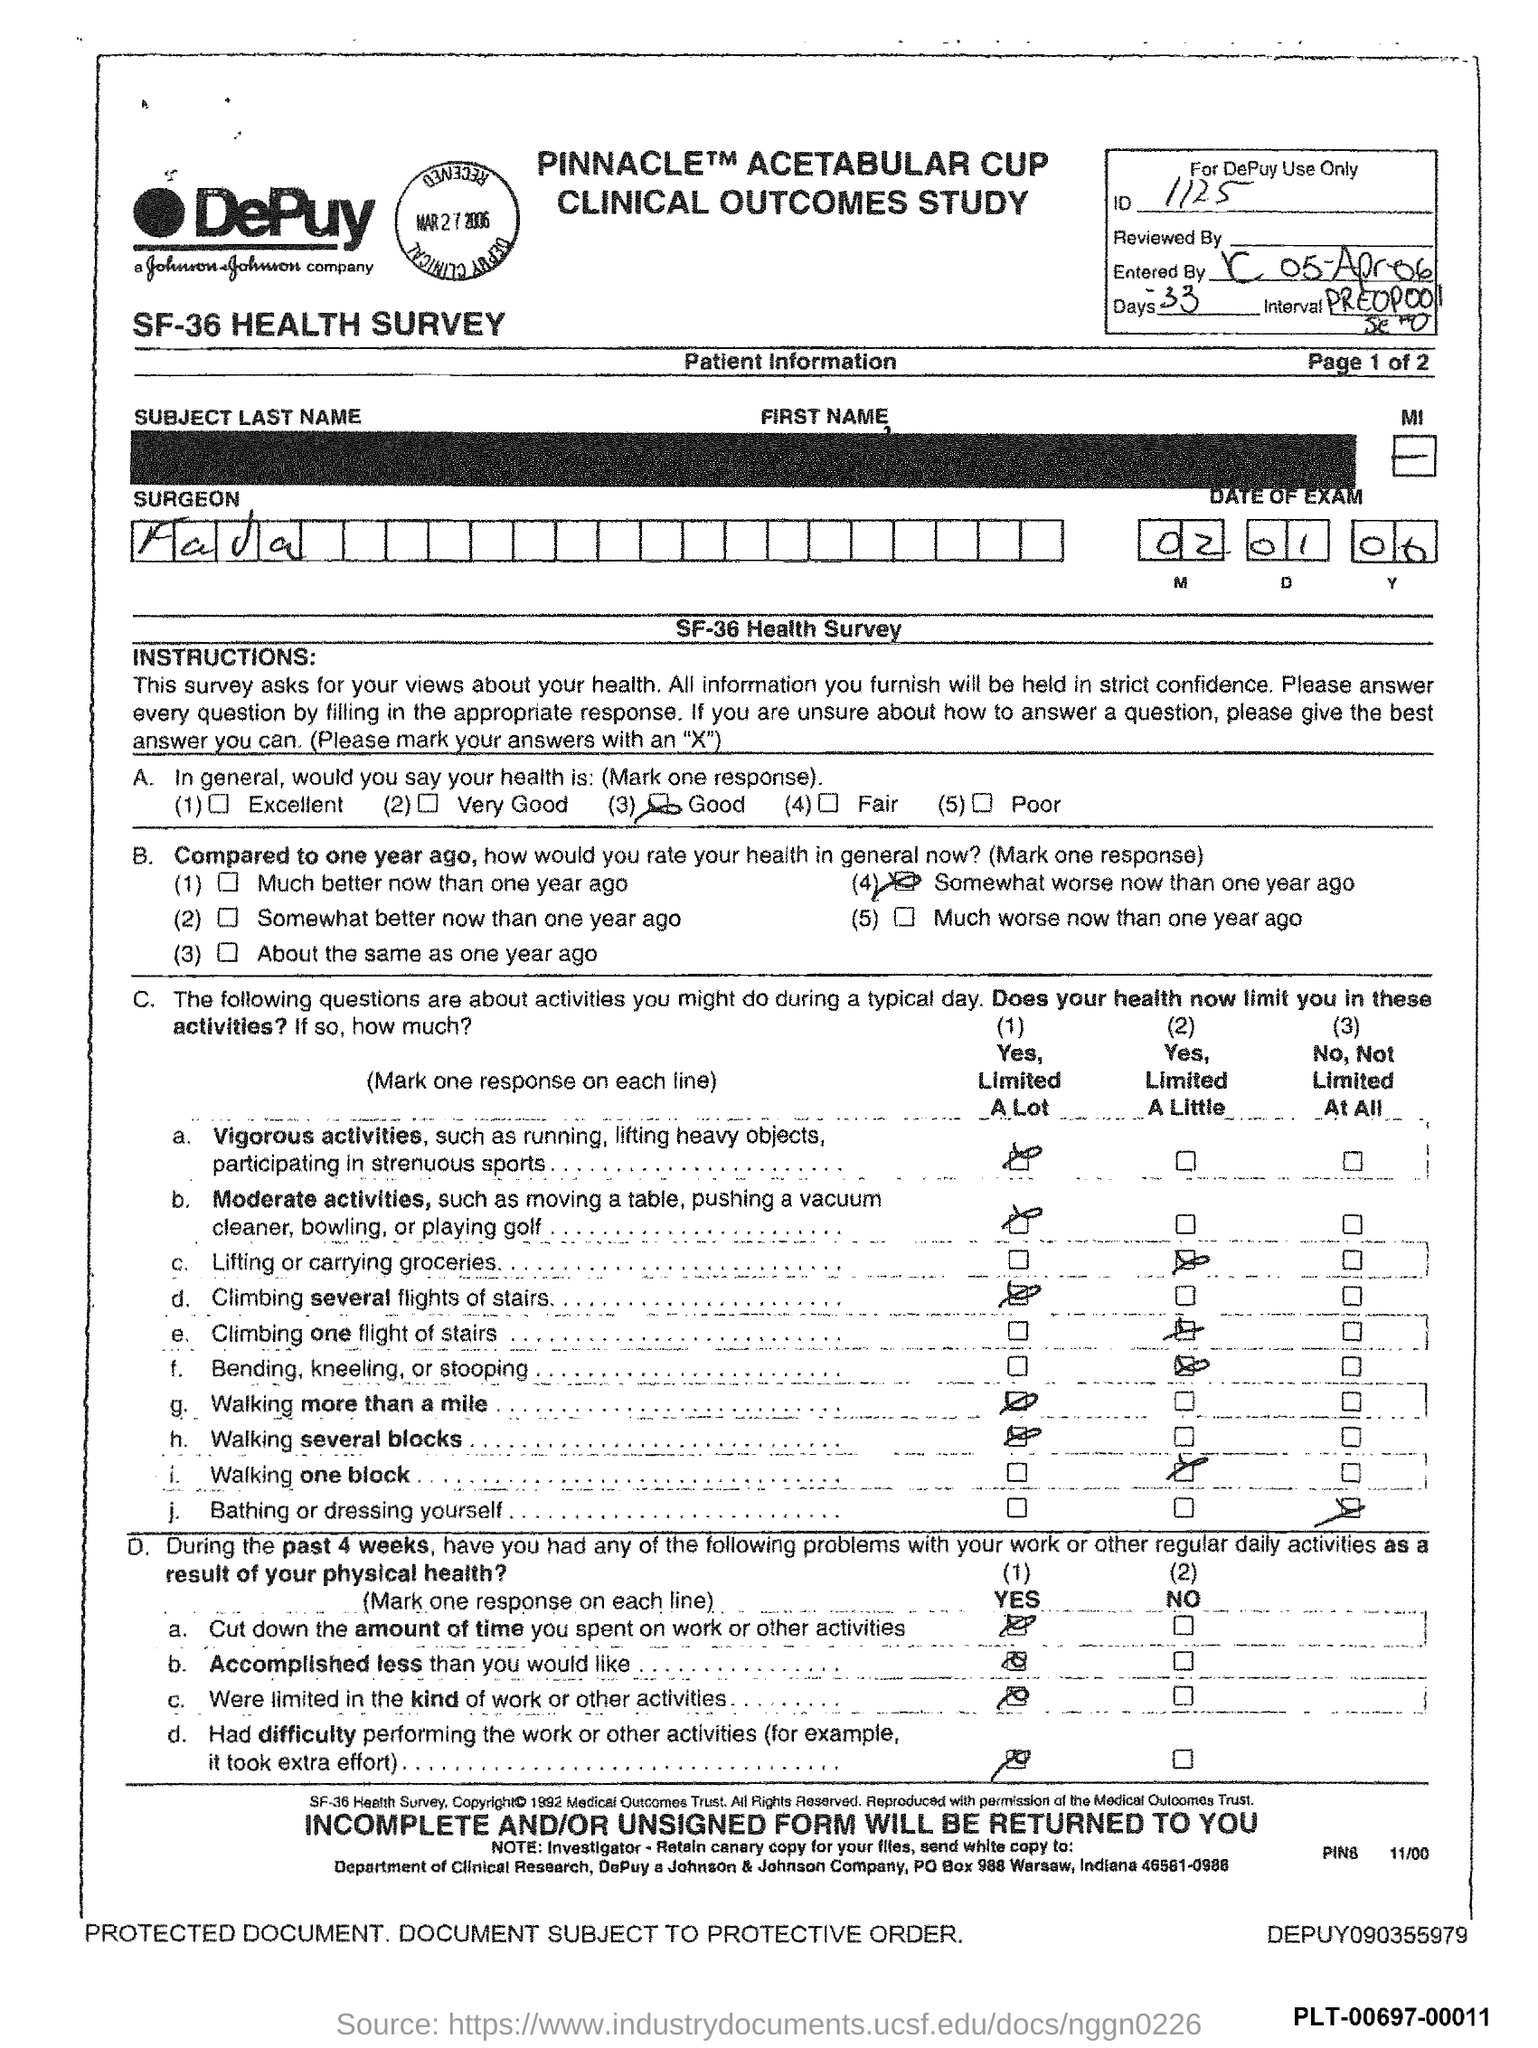Give some essential details in this illustration. The date of the exam mentioned in the document is January 2, 2006. 